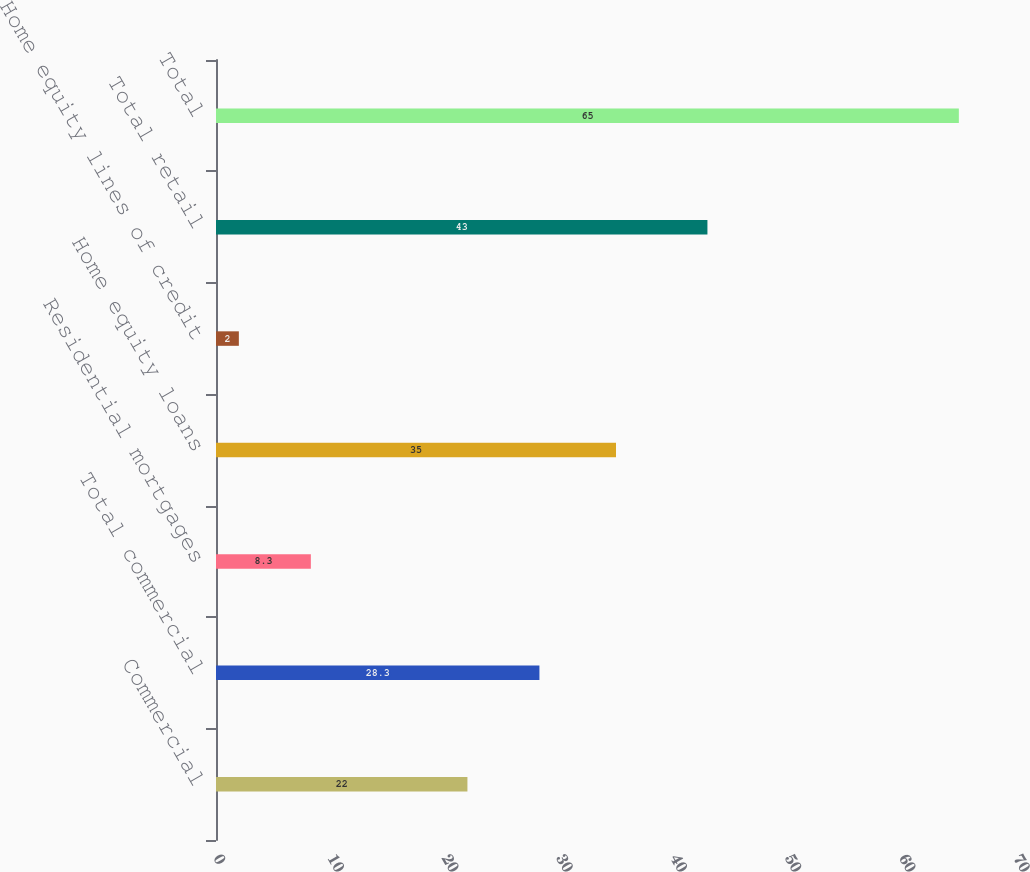<chart> <loc_0><loc_0><loc_500><loc_500><bar_chart><fcel>Commercial<fcel>Total commercial<fcel>Residential mortgages<fcel>Home equity loans<fcel>Home equity lines of credit<fcel>Total retail<fcel>Total<nl><fcel>22<fcel>28.3<fcel>8.3<fcel>35<fcel>2<fcel>43<fcel>65<nl></chart> 